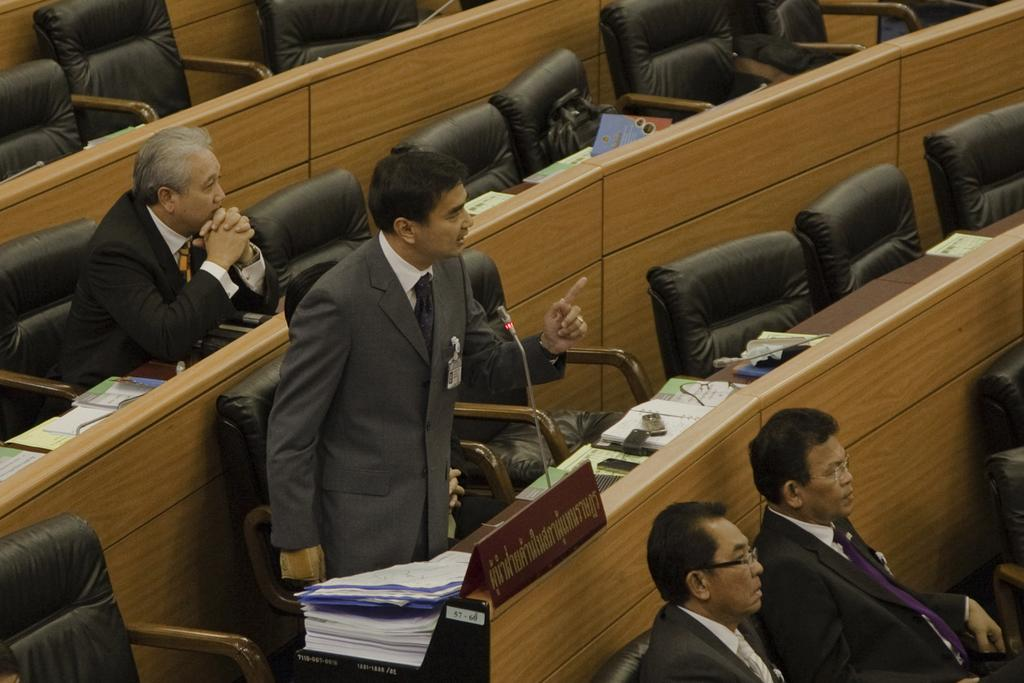Who or what can be seen in the image? There are people in the image. What is present on the table in the image? There are objects on a table in the image. What is written or displayed on the board in the image? There is a board with text in the image. What device is used for amplifying sound in the image? There is a microphone (mike) in the image. What time of day is it in the image, specifically in the afternoon? The time of day is not mentioned or depicted in the image, so it cannot be determined if it is in the afternoon. 